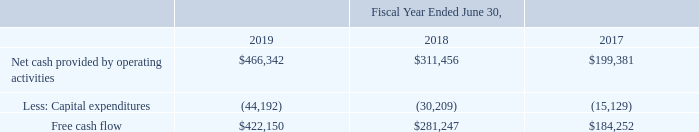Free Cash Flow
Free cash flow is a non-IFRS financial measure that we calculate as net cash provided by operating activities less net cash used in investing activities for capital expenditures.
Free cash flow increased by $140.9 million during the fiscal year ended June 30, 2019 due to a $154.9 million increase of net cash provided by operating activities, offset by a $14.0 million increase of capital expenditures as we continue to invest in our facilities.
For more information about net cash provided by operating activities, please see “Liquidity and Capital Resources”.
How is free cash flow calculated? Net cash provided by operating activities less net cash used in investing activities for capital expenditures. What was the increase in free cash flow between fiscal year 2018 and 2019? $140.9 million. What is the amount of free cash flow in 2019?
Answer scale should be: thousand. $422,150. What is the average net cash provided by operating activities from 2017-2019?
Answer scale should be: thousand. (466,342+311,456+199,381)/3
Answer: 325726.33. What is the percentage change in free cash flow between 2017 and 2018?
Answer scale should be: percent. (281,247-184,252)/184,252
Answer: 52.64. What is the change in capital expenditures between 2018 and 2019?
Answer scale should be: thousand. -44,192-(-30,209)
Answer: -13983. 